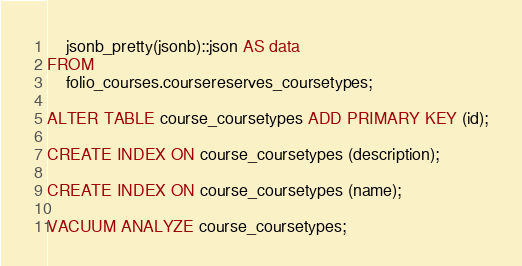Convert code to text. <code><loc_0><loc_0><loc_500><loc_500><_SQL_>    jsonb_pretty(jsonb)::json AS data
FROM
    folio_courses.coursereserves_coursetypes;

ALTER TABLE course_coursetypes ADD PRIMARY KEY (id);

CREATE INDEX ON course_coursetypes (description);

CREATE INDEX ON course_coursetypes (name);

VACUUM ANALYZE course_coursetypes;
</code> 